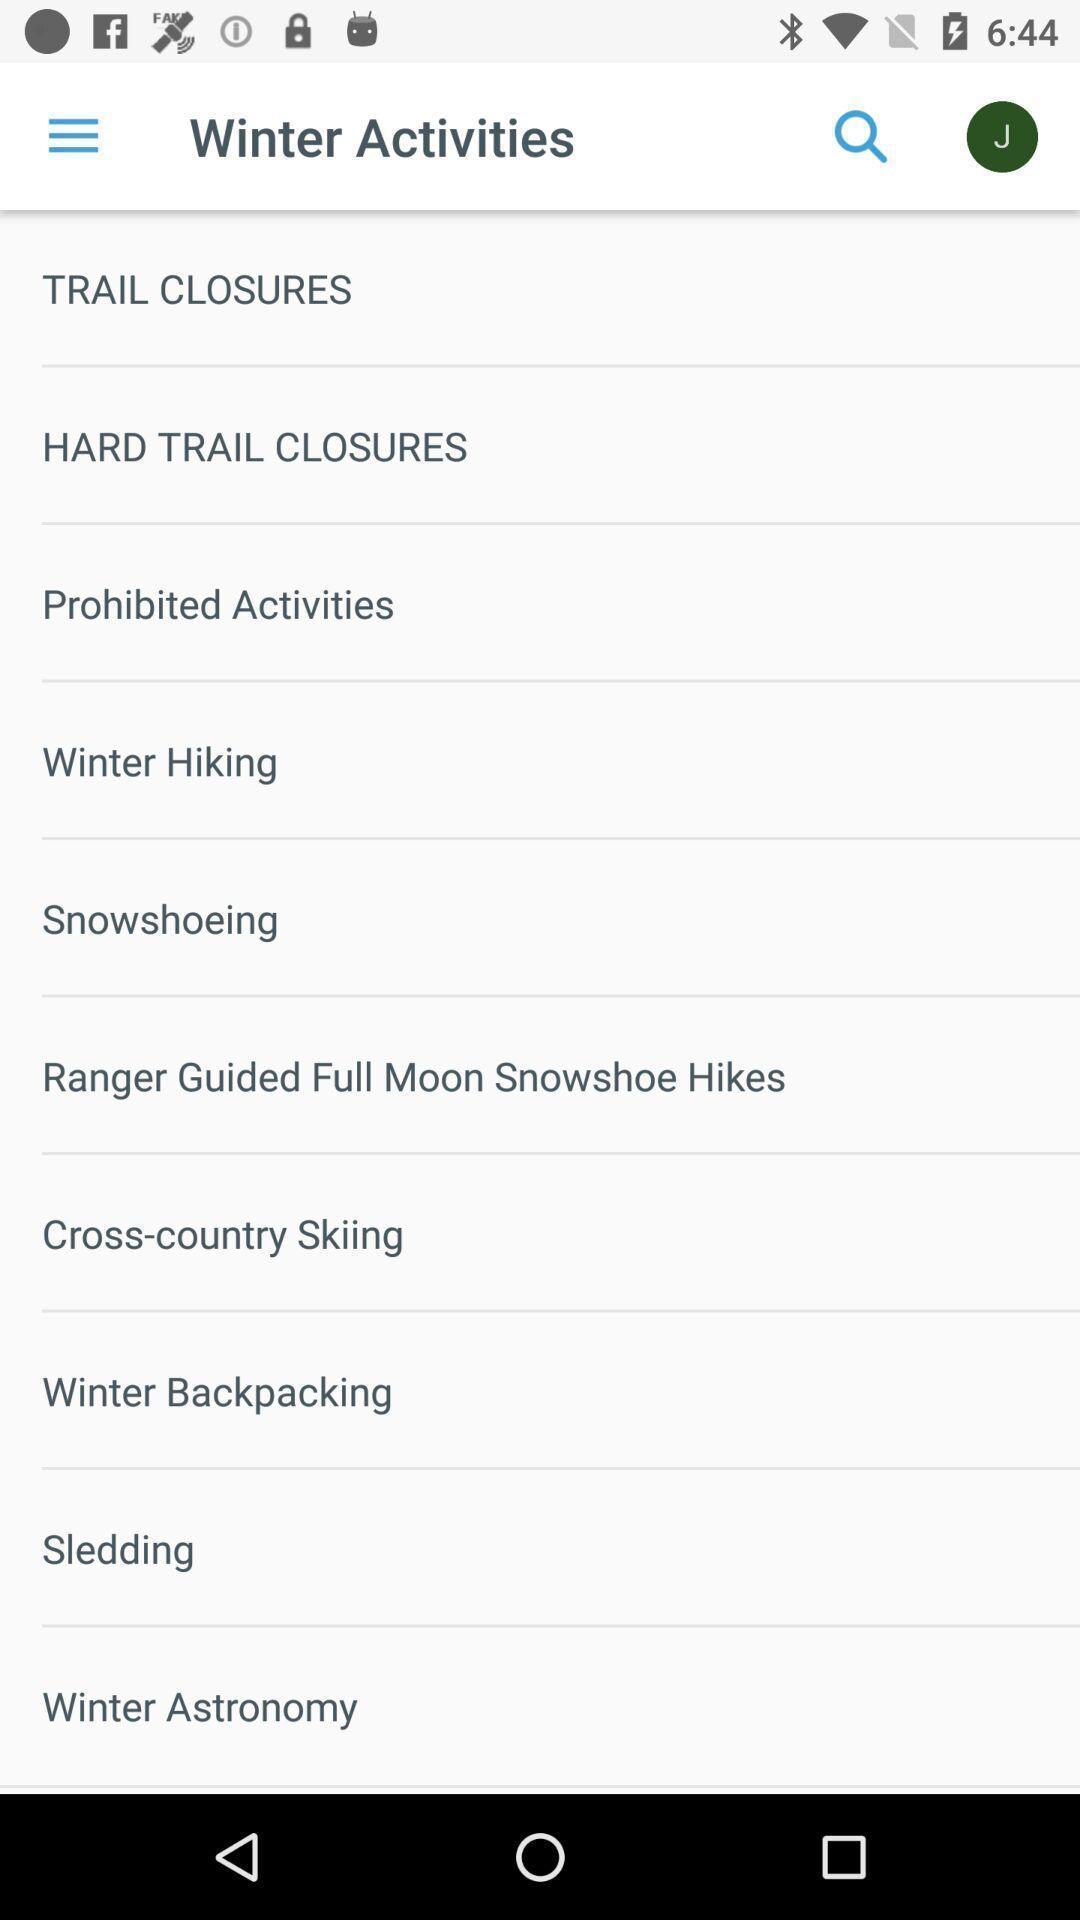Tell me about the visual elements in this screen capture. Screen displaying all the activities. 